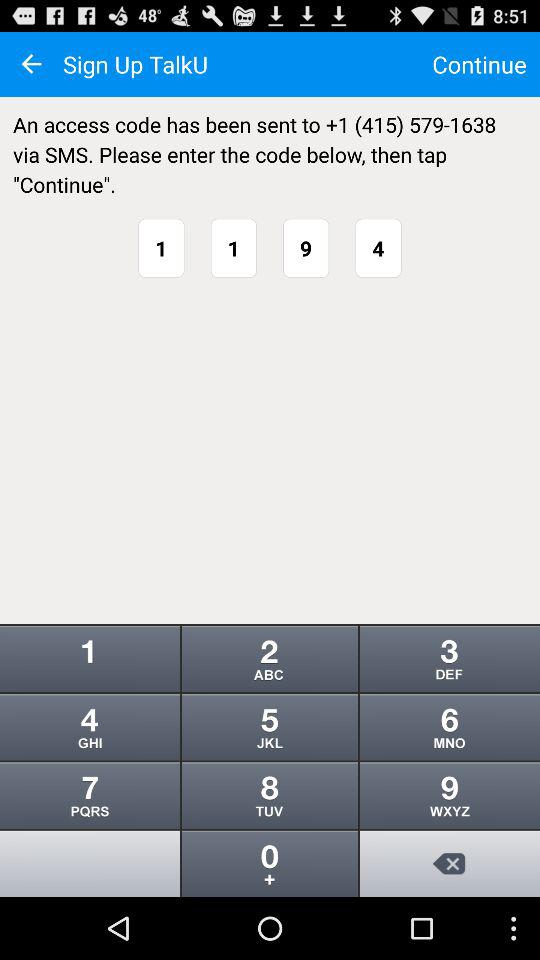What is the application name? The application name is "TalkU". 